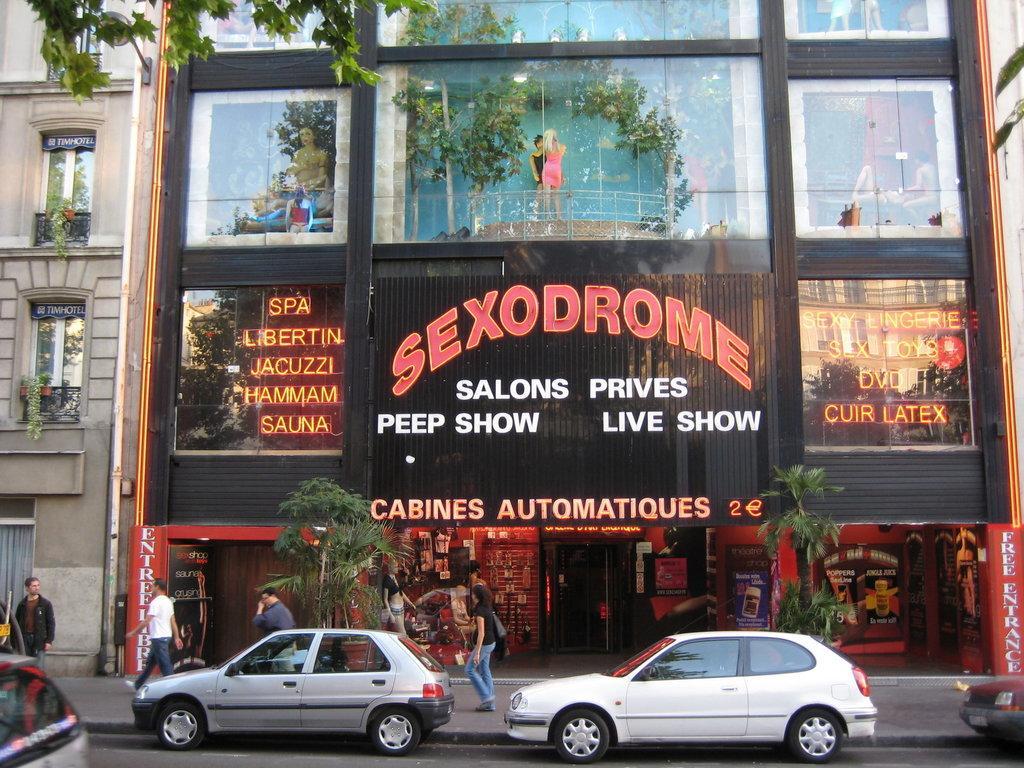In one or two sentences, can you explain what this image depicts? In this image, in the middle, we can see two cars which are moving on the road. On the right side, we can see the front side of a car which is on the road. On the left side, we can also see the back side of the car which is on the road. In the background, we can see a group of people walking on the footpath, trees, building, glass window, board, on the board, we can see some text is written on it, balcony. At the bottom, we can see footpath and a road. 